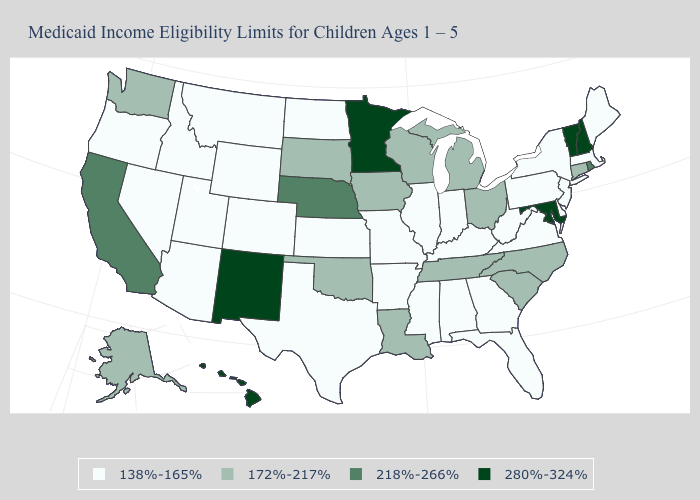Does the first symbol in the legend represent the smallest category?
Short answer required. Yes. Name the states that have a value in the range 172%-217%?
Quick response, please. Alaska, Connecticut, Iowa, Louisiana, Michigan, North Carolina, Ohio, Oklahoma, South Carolina, South Dakota, Tennessee, Washington, Wisconsin. Does the map have missing data?
Keep it brief. No. Name the states that have a value in the range 172%-217%?
Be succinct. Alaska, Connecticut, Iowa, Louisiana, Michigan, North Carolina, Ohio, Oklahoma, South Carolina, South Dakota, Tennessee, Washington, Wisconsin. Does Illinois have the lowest value in the MidWest?
Be succinct. Yes. What is the value of Georgia?
Short answer required. 138%-165%. What is the value of Utah?
Keep it brief. 138%-165%. What is the highest value in states that border Illinois?
Concise answer only. 172%-217%. Does Wisconsin have the lowest value in the MidWest?
Short answer required. No. Is the legend a continuous bar?
Concise answer only. No. Does Ohio have the lowest value in the MidWest?
Short answer required. No. Which states have the lowest value in the Northeast?
Give a very brief answer. Maine, Massachusetts, New Jersey, New York, Pennsylvania. Name the states that have a value in the range 218%-266%?
Short answer required. California, Nebraska, Rhode Island. Among the states that border Nebraska , does Wyoming have the lowest value?
Short answer required. Yes. What is the highest value in the South ?
Write a very short answer. 280%-324%. 